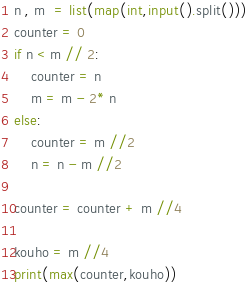<code> <loc_0><loc_0><loc_500><loc_500><_Python_>n , m  = list(map(int,input().split()))
counter = 0
if n < m // 2:
    counter = n
    m = m - 2* n
else:
    counter = m //2
    n = n - m //2

counter = counter + m //4 

kouho = m //4
print(max(counter,kouho))</code> 